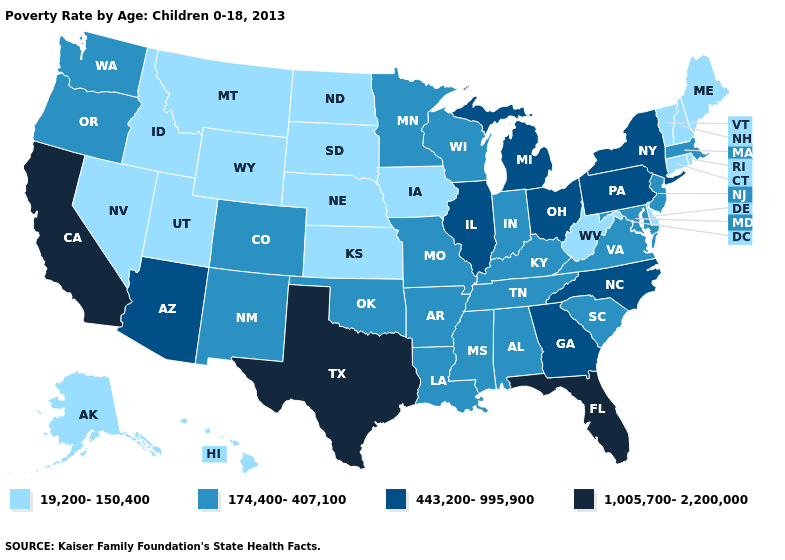Name the states that have a value in the range 1,005,700-2,200,000?
Concise answer only. California, Florida, Texas. Name the states that have a value in the range 19,200-150,400?
Concise answer only. Alaska, Connecticut, Delaware, Hawaii, Idaho, Iowa, Kansas, Maine, Montana, Nebraska, Nevada, New Hampshire, North Dakota, Rhode Island, South Dakota, Utah, Vermont, West Virginia, Wyoming. What is the lowest value in the MidWest?
Be succinct. 19,200-150,400. Does the first symbol in the legend represent the smallest category?
Concise answer only. Yes. Name the states that have a value in the range 1,005,700-2,200,000?
Give a very brief answer. California, Florida, Texas. Does California have a higher value than Alaska?
Concise answer only. Yes. Does Tennessee have a lower value than Kentucky?
Be succinct. No. What is the lowest value in the USA?
Give a very brief answer. 19,200-150,400. Name the states that have a value in the range 1,005,700-2,200,000?
Concise answer only. California, Florida, Texas. What is the highest value in the West ?
Be succinct. 1,005,700-2,200,000. Does the first symbol in the legend represent the smallest category?
Write a very short answer. Yes. Does Rhode Island have the lowest value in the Northeast?
Short answer required. Yes. What is the value of Nebraska?
Keep it brief. 19,200-150,400. What is the lowest value in the South?
Keep it brief. 19,200-150,400. Does the map have missing data?
Keep it brief. No. 